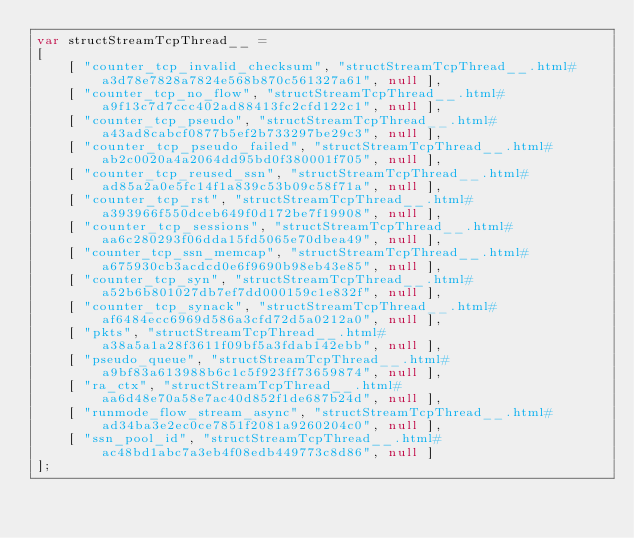<code> <loc_0><loc_0><loc_500><loc_500><_JavaScript_>var structStreamTcpThread__ =
[
    [ "counter_tcp_invalid_checksum", "structStreamTcpThread__.html#a3d78e7828a7824e568b870c561327a61", null ],
    [ "counter_tcp_no_flow", "structStreamTcpThread__.html#a9f13c7d7ccc402ad88413fc2cfd122c1", null ],
    [ "counter_tcp_pseudo", "structStreamTcpThread__.html#a43ad8cabcf0877b5ef2b733297be29c3", null ],
    [ "counter_tcp_pseudo_failed", "structStreamTcpThread__.html#ab2c0020a4a2064dd95bd0f380001f705", null ],
    [ "counter_tcp_reused_ssn", "structStreamTcpThread__.html#ad85a2a0e5fc14f1a839c53b09c58f71a", null ],
    [ "counter_tcp_rst", "structStreamTcpThread__.html#a393966f550dceb649f0d172be7f19908", null ],
    [ "counter_tcp_sessions", "structStreamTcpThread__.html#aa6c280293f06dda15fd5065e70dbea49", null ],
    [ "counter_tcp_ssn_memcap", "structStreamTcpThread__.html#a675930cb3acdcd0e6f9690b98eb43e85", null ],
    [ "counter_tcp_syn", "structStreamTcpThread__.html#a52b6b801027db7ef7dd000159c1e832f", null ],
    [ "counter_tcp_synack", "structStreamTcpThread__.html#af6484ecc6969d586a3cfd72d5a0212a0", null ],
    [ "pkts", "structStreamTcpThread__.html#a38a5a1a28f3611f09bf5a3fdab142ebb", null ],
    [ "pseudo_queue", "structStreamTcpThread__.html#a9bf83a613988b6c1c5f923ff73659874", null ],
    [ "ra_ctx", "structStreamTcpThread__.html#aa6d48e70a58e7ac40d852f1de687b24d", null ],
    [ "runmode_flow_stream_async", "structStreamTcpThread__.html#ad34ba3e2ec0ce7851f2081a9260204c0", null ],
    [ "ssn_pool_id", "structStreamTcpThread__.html#ac48bd1abc7a3eb4f08edb449773c8d86", null ]
];</code> 